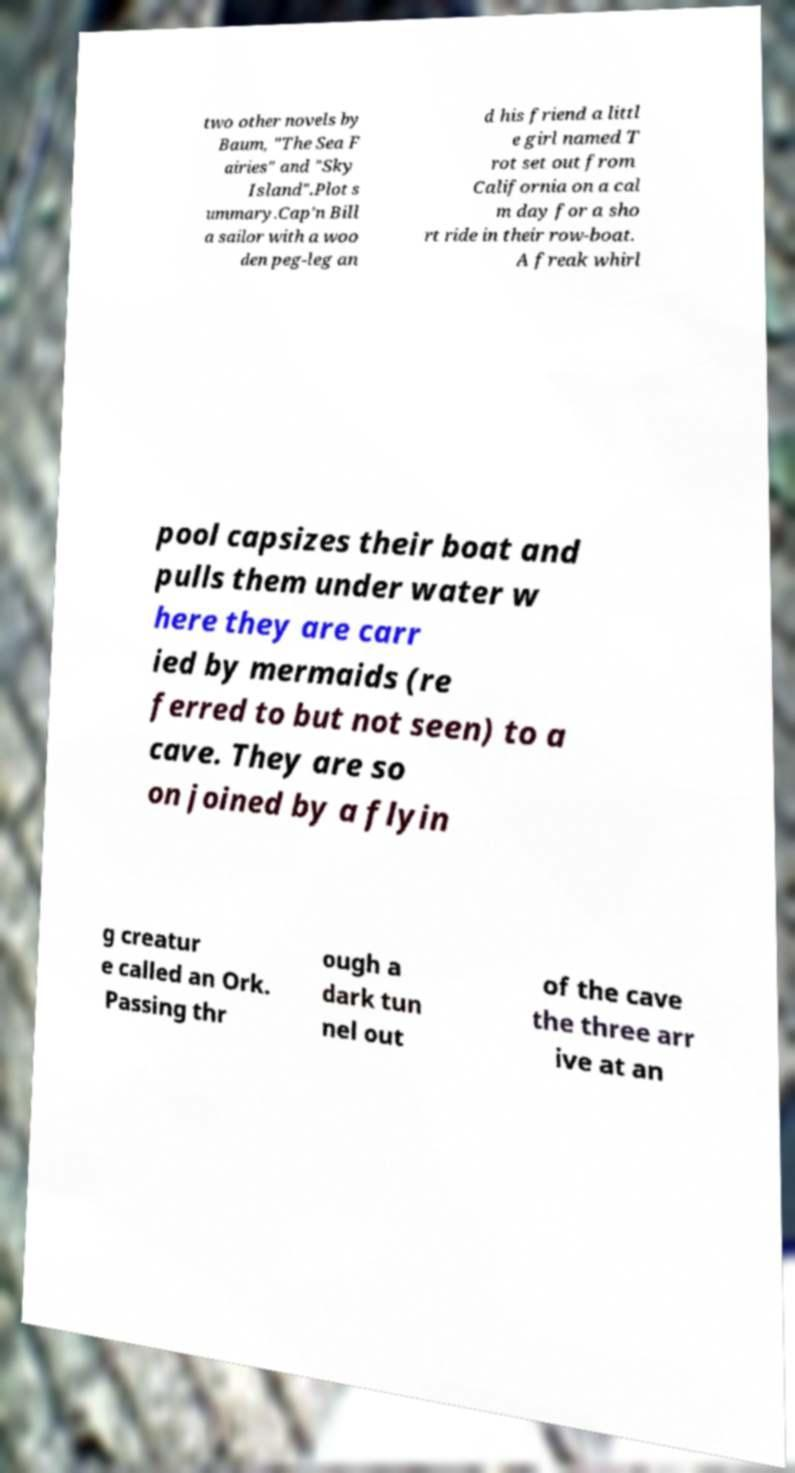I need the written content from this picture converted into text. Can you do that? two other novels by Baum, "The Sea F airies" and "Sky Island".Plot s ummary.Cap'n Bill a sailor with a woo den peg-leg an d his friend a littl e girl named T rot set out from California on a cal m day for a sho rt ride in their row-boat. A freak whirl pool capsizes their boat and pulls them under water w here they are carr ied by mermaids (re ferred to but not seen) to a cave. They are so on joined by a flyin g creatur e called an Ork. Passing thr ough a dark tun nel out of the cave the three arr ive at an 